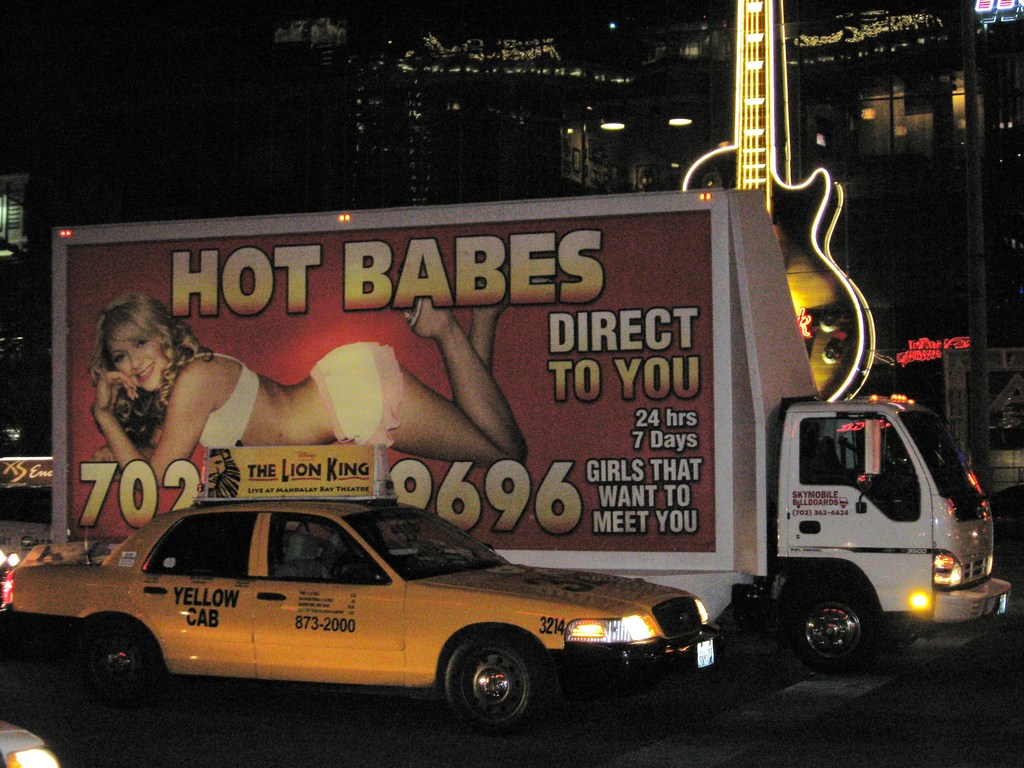Can you describe the types of vehicles visible in the image and their possible roles in this urban setting? The image features two main types of vehicles: a billboard truck and a yellow taxi. The billboard truck is used for mobile advertising, effectively bringing the advertisement directly to consumers throughout the city. The yellow taxi, known for its convenience, is essential for transporting residents and tourists alike, facilitating easy travel across the city especially during busy nightlife hours. 